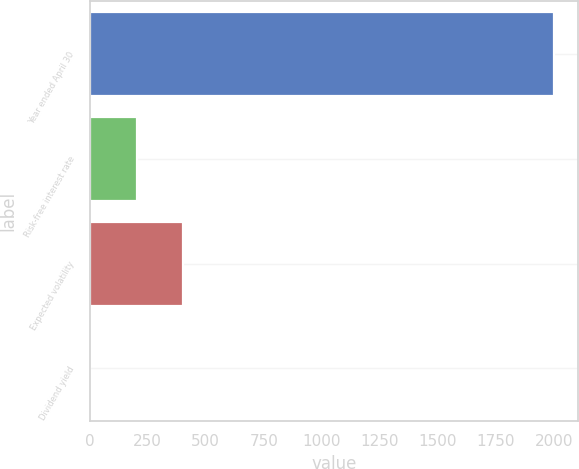<chart> <loc_0><loc_0><loc_500><loc_500><bar_chart><fcel>Year ended April 30<fcel>Risk-free interest rate<fcel>Expected volatility<fcel>Dividend yield<nl><fcel>2003<fcel>201.65<fcel>401.8<fcel>1.5<nl></chart> 